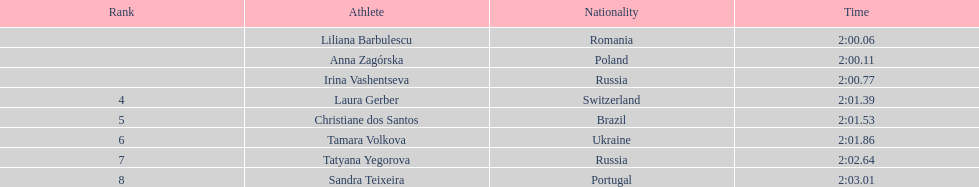Which women competitors were involved in the 2003 summer universiade - women's 800 meters? Liliana Barbulescu, Anna Zagórska, Irina Vashentseva, Laura Gerber, Christiane dos Santos, Tamara Volkova, Tatyana Yegorova, Sandra Teixeira. From them, who are polish representatives? Anna Zagórska. What is her record? 2:00.11. 